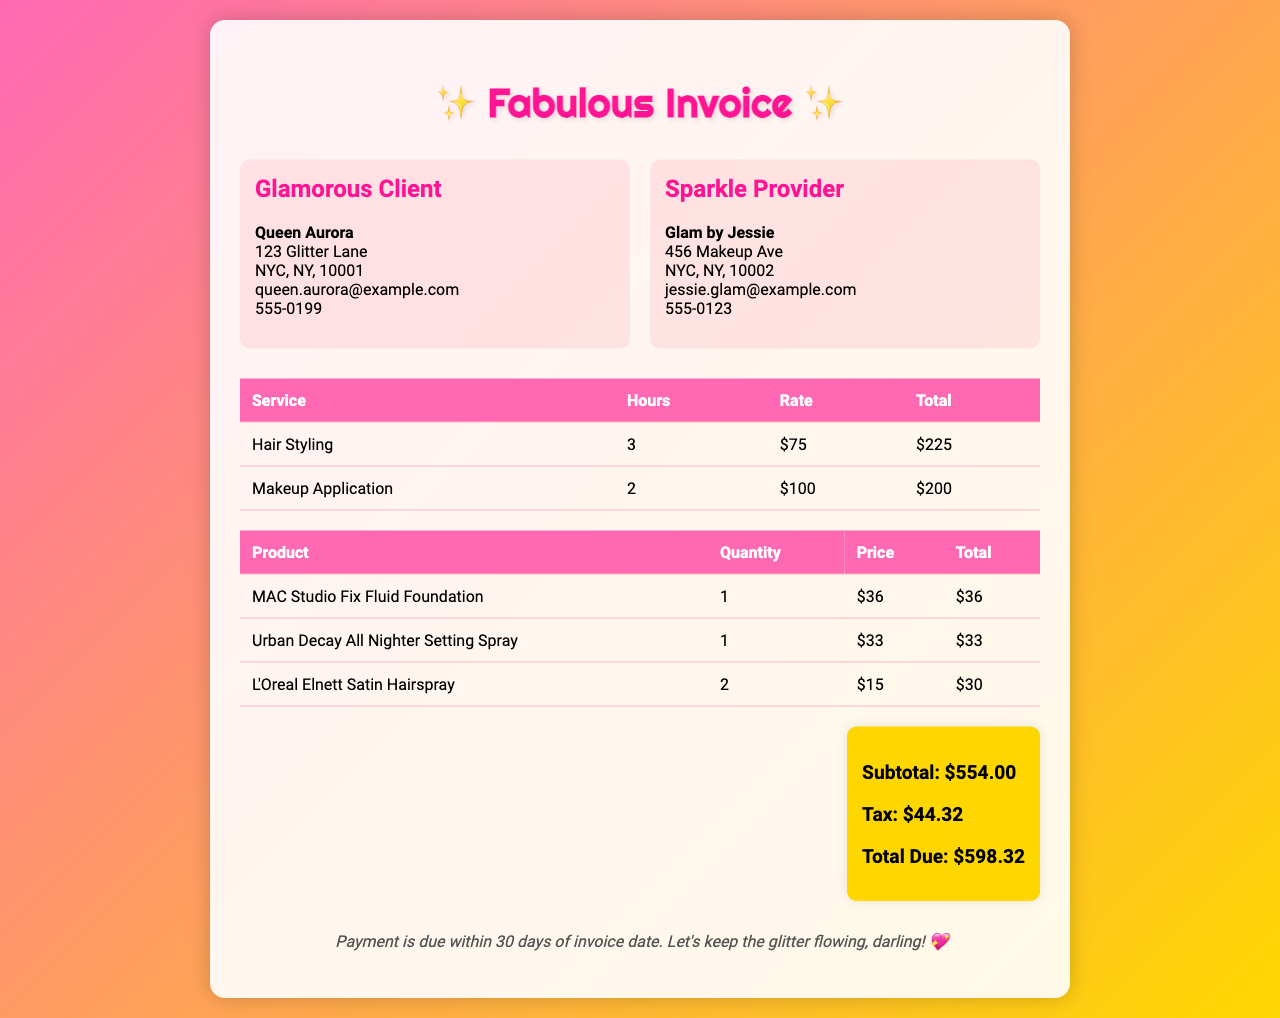what is the total due? The total due is found in the total section of the invoice indicating the final amount after tax.
Answer: $598.32 who is the client? The client's name is provided in the information section under 'Glamorous Client.'
Answer: Queen Aurora how many hours were spent on Hair Styling? The number of hours for Hair Styling is specified in the service table.
Answer: 3 what is the rate for Makeup Application? The rate is listed in the service table next to the Makeup Application service.
Answer: $100 which product has the highest price? The highest price of a product can be found in the product table.
Answer: MAC Studio Fix Fluid Foundation how many products were listed in the invoice? The total number of products can be calculated from the product table rows.
Answer: 3 what is the tax amount? The tax amount is detailed in the total section of the invoice.
Answer: $44.32 who provided the services? The service provider's name is indicated in the 'Sparkle Provider' section.
Answer: Glam by Jessie what is the total for Hair Styling? The total for Hair Styling is indicated in the service table under the total column.
Answer: $225 when is the payment due? The payment terms specify when payment is expected.
Answer: Within 30 days 